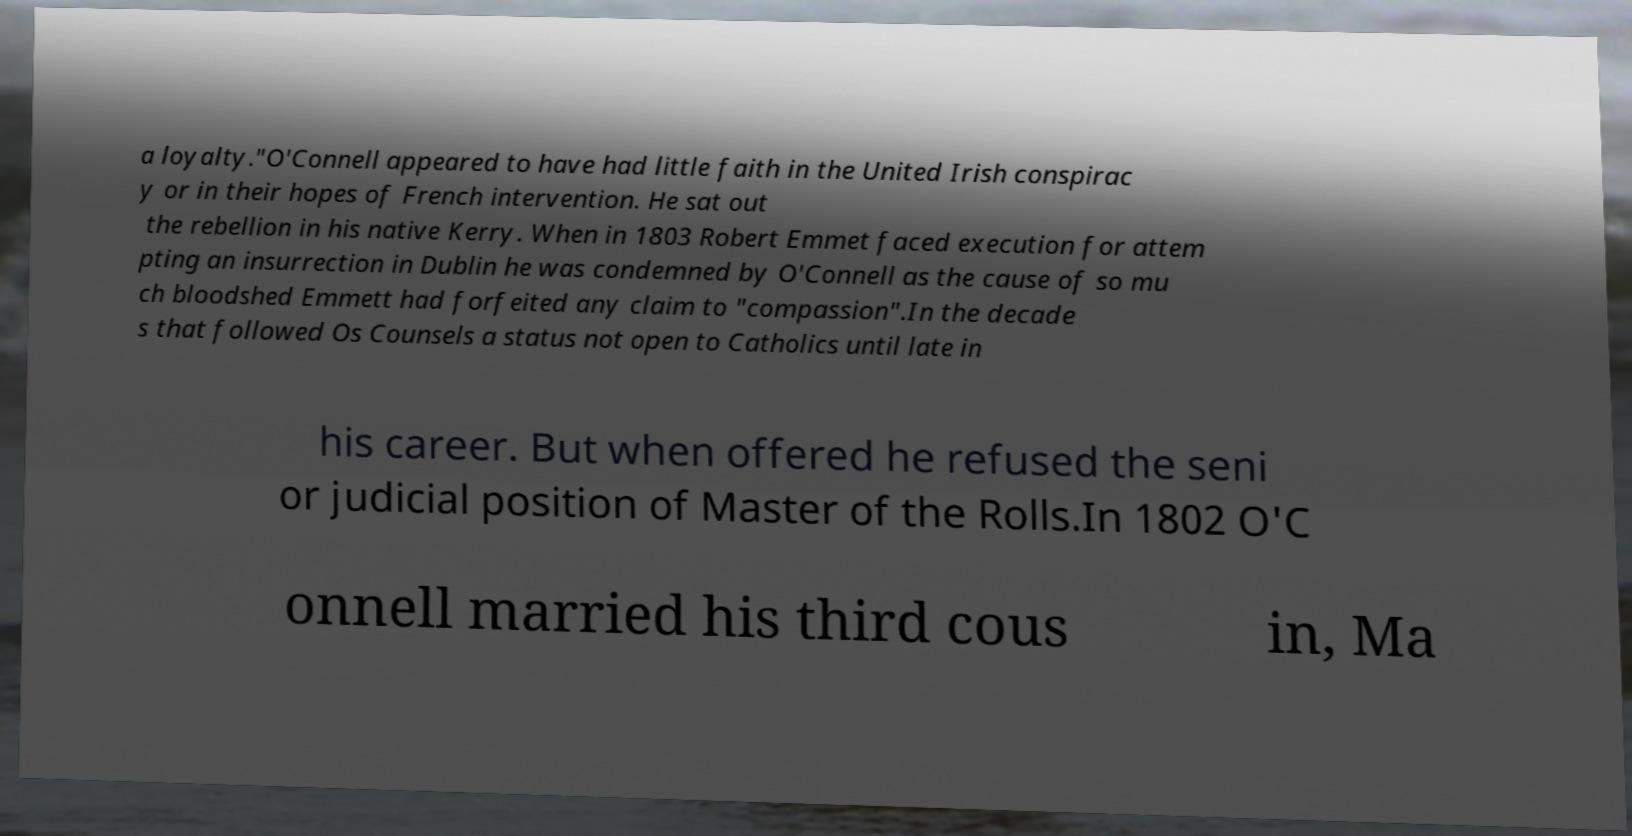There's text embedded in this image that I need extracted. Can you transcribe it verbatim? a loyalty."O'Connell appeared to have had little faith in the United Irish conspirac y or in their hopes of French intervention. He sat out the rebellion in his native Kerry. When in 1803 Robert Emmet faced execution for attem pting an insurrection in Dublin he was condemned by O'Connell as the cause of so mu ch bloodshed Emmett had forfeited any claim to "compassion".In the decade s that followed Os Counsels a status not open to Catholics until late in his career. But when offered he refused the seni or judicial position of Master of the Rolls.In 1802 O'C onnell married his third cous in, Ma 